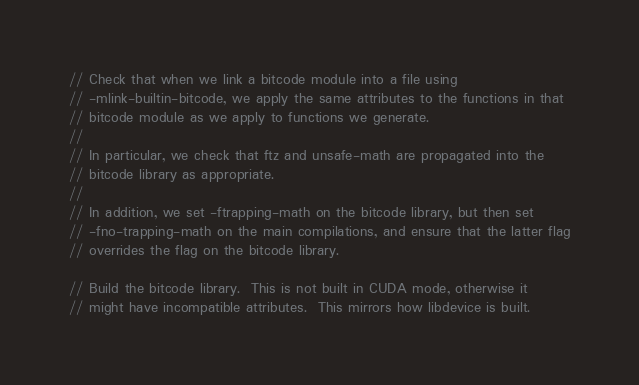Convert code to text. <code><loc_0><loc_0><loc_500><loc_500><_Cuda_>// Check that when we link a bitcode module into a file using
// -mlink-builtin-bitcode, we apply the same attributes to the functions in that
// bitcode module as we apply to functions we generate.
//
// In particular, we check that ftz and unsafe-math are propagated into the
// bitcode library as appropriate.
//
// In addition, we set -ftrapping-math on the bitcode library, but then set
// -fno-trapping-math on the main compilations, and ensure that the latter flag
// overrides the flag on the bitcode library.

// Build the bitcode library.  This is not built in CUDA mode, otherwise it
// might have incompatible attributes.  This mirrors how libdevice is built.</code> 